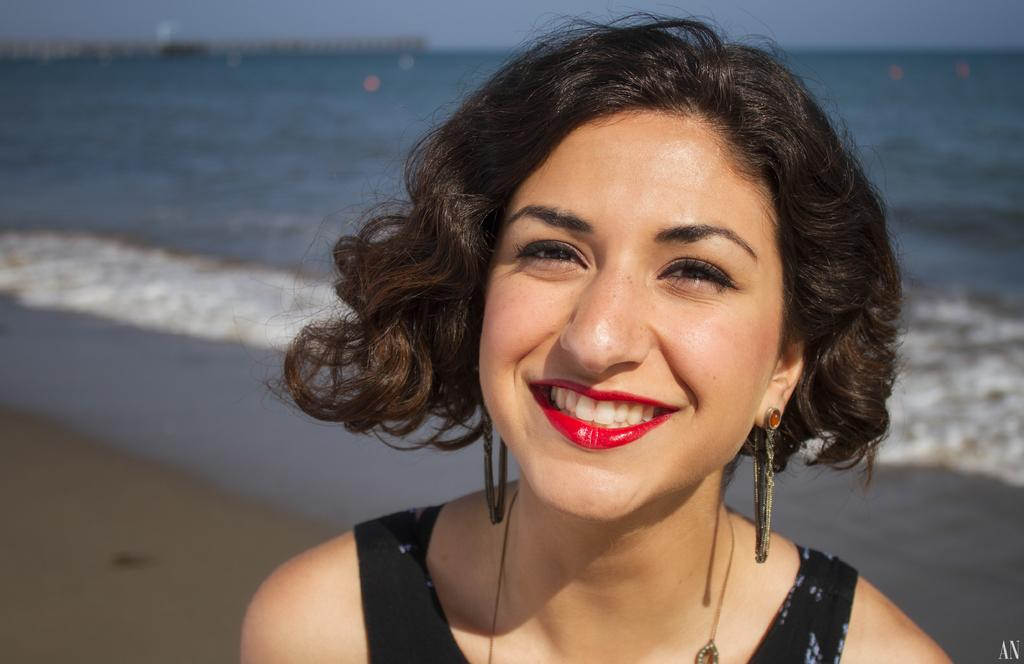What is the main subject of the image? There is a woman in the image. What is the woman wearing? The woman is wearing a black dress. Can you describe any additional details about the woman's appearance? The woman is wearing red lipstick. What is the woman's facial expression? The woman is smiling. What can be seen in the background of the image? There is sand, water, and the sky visible in the background of the image. What type of event is the woman attending in the image? There is no indication of an event in the image; it simply shows a woman smiling. What is the friction between the woman and the sand in the image? There is no friction mentioned or depicted in the image, as the woman is not interacting with the sand. 